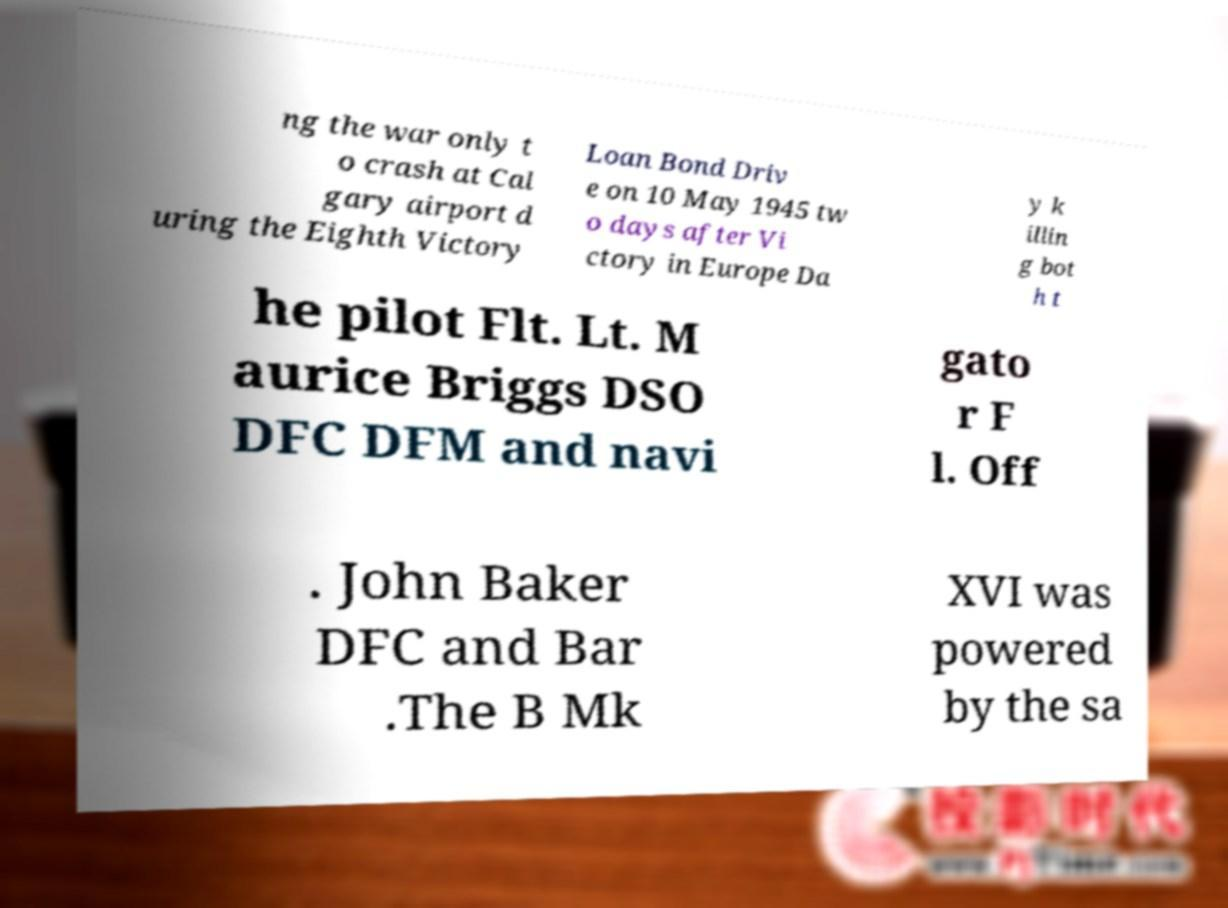Can you accurately transcribe the text from the provided image for me? ng the war only t o crash at Cal gary airport d uring the Eighth Victory Loan Bond Driv e on 10 May 1945 tw o days after Vi ctory in Europe Da y k illin g bot h t he pilot Flt. Lt. M aurice Briggs DSO DFC DFM and navi gato r F l. Off . John Baker DFC and Bar .The B Mk XVI was powered by the sa 